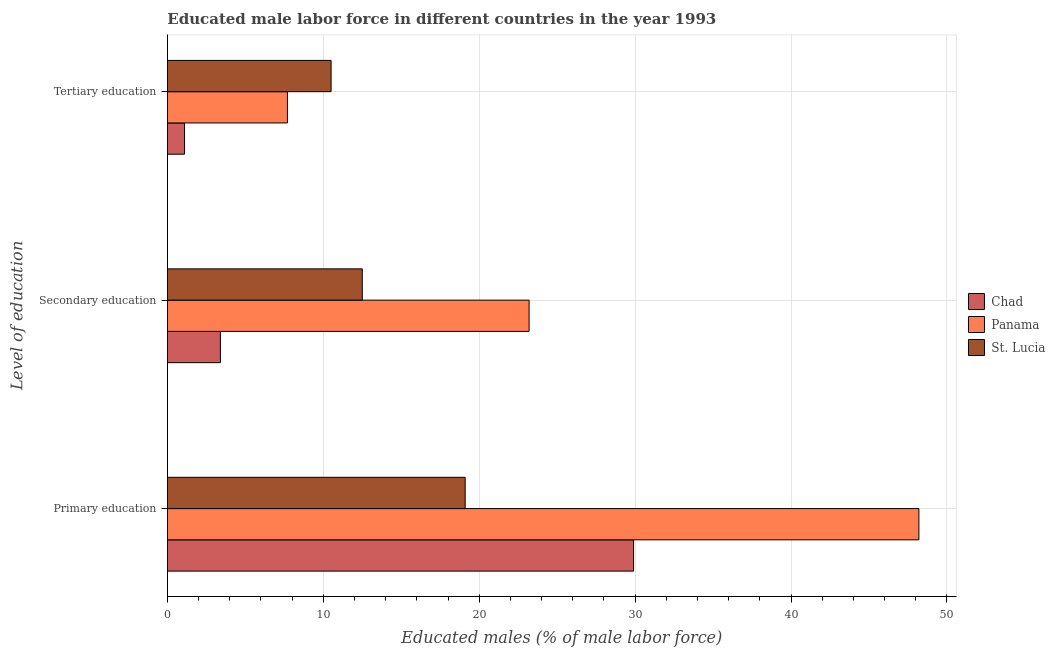How many groups of bars are there?
Ensure brevity in your answer.  3. Are the number of bars per tick equal to the number of legend labels?
Make the answer very short. Yes. What is the label of the 2nd group of bars from the top?
Your answer should be compact. Secondary education. What is the percentage of male labor force who received tertiary education in St. Lucia?
Your response must be concise. 10.5. Across all countries, what is the maximum percentage of male labor force who received primary education?
Offer a very short reply. 48.2. Across all countries, what is the minimum percentage of male labor force who received secondary education?
Make the answer very short. 3.4. In which country was the percentage of male labor force who received tertiary education maximum?
Offer a terse response. St. Lucia. In which country was the percentage of male labor force who received secondary education minimum?
Your response must be concise. Chad. What is the total percentage of male labor force who received primary education in the graph?
Make the answer very short. 97.2. What is the difference between the percentage of male labor force who received primary education in Chad and that in St. Lucia?
Your answer should be compact. 10.8. What is the difference between the percentage of male labor force who received secondary education in Chad and the percentage of male labor force who received primary education in St. Lucia?
Provide a short and direct response. -15.7. What is the average percentage of male labor force who received primary education per country?
Provide a short and direct response. 32.4. What is the difference between the percentage of male labor force who received primary education and percentage of male labor force who received tertiary education in Panama?
Provide a short and direct response. 40.5. What is the ratio of the percentage of male labor force who received tertiary education in Chad to that in Panama?
Offer a very short reply. 0.14. Is the percentage of male labor force who received primary education in Panama less than that in Chad?
Ensure brevity in your answer.  No. Is the difference between the percentage of male labor force who received secondary education in Panama and St. Lucia greater than the difference between the percentage of male labor force who received tertiary education in Panama and St. Lucia?
Provide a succinct answer. Yes. What is the difference between the highest and the second highest percentage of male labor force who received tertiary education?
Provide a short and direct response. 2.8. What is the difference between the highest and the lowest percentage of male labor force who received secondary education?
Your answer should be compact. 19.8. Is the sum of the percentage of male labor force who received secondary education in Chad and St. Lucia greater than the maximum percentage of male labor force who received primary education across all countries?
Provide a short and direct response. No. What does the 2nd bar from the top in Tertiary education represents?
Ensure brevity in your answer.  Panama. What does the 1st bar from the bottom in Primary education represents?
Ensure brevity in your answer.  Chad. Is it the case that in every country, the sum of the percentage of male labor force who received primary education and percentage of male labor force who received secondary education is greater than the percentage of male labor force who received tertiary education?
Your answer should be very brief. Yes. How many bars are there?
Make the answer very short. 9. Are all the bars in the graph horizontal?
Ensure brevity in your answer.  Yes. Does the graph contain any zero values?
Provide a short and direct response. No. Does the graph contain grids?
Your answer should be compact. Yes. How many legend labels are there?
Offer a terse response. 3. What is the title of the graph?
Provide a short and direct response. Educated male labor force in different countries in the year 1993. What is the label or title of the X-axis?
Ensure brevity in your answer.  Educated males (% of male labor force). What is the label or title of the Y-axis?
Make the answer very short. Level of education. What is the Educated males (% of male labor force) in Chad in Primary education?
Offer a terse response. 29.9. What is the Educated males (% of male labor force) of Panama in Primary education?
Make the answer very short. 48.2. What is the Educated males (% of male labor force) in St. Lucia in Primary education?
Give a very brief answer. 19.1. What is the Educated males (% of male labor force) in Chad in Secondary education?
Provide a short and direct response. 3.4. What is the Educated males (% of male labor force) in Panama in Secondary education?
Ensure brevity in your answer.  23.2. What is the Educated males (% of male labor force) of St. Lucia in Secondary education?
Your answer should be very brief. 12.5. What is the Educated males (% of male labor force) in Chad in Tertiary education?
Offer a terse response. 1.1. What is the Educated males (% of male labor force) of Panama in Tertiary education?
Your answer should be compact. 7.7. What is the Educated males (% of male labor force) in St. Lucia in Tertiary education?
Ensure brevity in your answer.  10.5. Across all Level of education, what is the maximum Educated males (% of male labor force) in Chad?
Offer a terse response. 29.9. Across all Level of education, what is the maximum Educated males (% of male labor force) of Panama?
Keep it short and to the point. 48.2. Across all Level of education, what is the maximum Educated males (% of male labor force) in St. Lucia?
Keep it short and to the point. 19.1. Across all Level of education, what is the minimum Educated males (% of male labor force) of Chad?
Your answer should be compact. 1.1. Across all Level of education, what is the minimum Educated males (% of male labor force) in Panama?
Offer a terse response. 7.7. Across all Level of education, what is the minimum Educated males (% of male labor force) in St. Lucia?
Provide a succinct answer. 10.5. What is the total Educated males (% of male labor force) in Chad in the graph?
Make the answer very short. 34.4. What is the total Educated males (% of male labor force) of Panama in the graph?
Your response must be concise. 79.1. What is the total Educated males (% of male labor force) in St. Lucia in the graph?
Ensure brevity in your answer.  42.1. What is the difference between the Educated males (% of male labor force) of Chad in Primary education and that in Secondary education?
Offer a very short reply. 26.5. What is the difference between the Educated males (% of male labor force) of Panama in Primary education and that in Secondary education?
Make the answer very short. 25. What is the difference between the Educated males (% of male labor force) of Chad in Primary education and that in Tertiary education?
Give a very brief answer. 28.8. What is the difference between the Educated males (% of male labor force) in Panama in Primary education and that in Tertiary education?
Make the answer very short. 40.5. What is the difference between the Educated males (% of male labor force) in Chad in Secondary education and that in Tertiary education?
Offer a very short reply. 2.3. What is the difference between the Educated males (% of male labor force) of Chad in Primary education and the Educated males (% of male labor force) of St. Lucia in Secondary education?
Your answer should be compact. 17.4. What is the difference between the Educated males (% of male labor force) in Panama in Primary education and the Educated males (% of male labor force) in St. Lucia in Secondary education?
Keep it short and to the point. 35.7. What is the difference between the Educated males (% of male labor force) in Chad in Primary education and the Educated males (% of male labor force) in St. Lucia in Tertiary education?
Offer a very short reply. 19.4. What is the difference between the Educated males (% of male labor force) of Panama in Primary education and the Educated males (% of male labor force) of St. Lucia in Tertiary education?
Keep it short and to the point. 37.7. What is the difference between the Educated males (% of male labor force) of Chad in Secondary education and the Educated males (% of male labor force) of St. Lucia in Tertiary education?
Make the answer very short. -7.1. What is the difference between the Educated males (% of male labor force) in Panama in Secondary education and the Educated males (% of male labor force) in St. Lucia in Tertiary education?
Give a very brief answer. 12.7. What is the average Educated males (% of male labor force) of Chad per Level of education?
Ensure brevity in your answer.  11.47. What is the average Educated males (% of male labor force) of Panama per Level of education?
Your response must be concise. 26.37. What is the average Educated males (% of male labor force) in St. Lucia per Level of education?
Your response must be concise. 14.03. What is the difference between the Educated males (% of male labor force) of Chad and Educated males (% of male labor force) of Panama in Primary education?
Offer a very short reply. -18.3. What is the difference between the Educated males (% of male labor force) in Chad and Educated males (% of male labor force) in St. Lucia in Primary education?
Your response must be concise. 10.8. What is the difference between the Educated males (% of male labor force) of Panama and Educated males (% of male labor force) of St. Lucia in Primary education?
Your answer should be compact. 29.1. What is the difference between the Educated males (% of male labor force) in Chad and Educated males (% of male labor force) in Panama in Secondary education?
Your response must be concise. -19.8. What is the difference between the Educated males (% of male labor force) of Chad and Educated males (% of male labor force) of St. Lucia in Secondary education?
Keep it short and to the point. -9.1. What is the difference between the Educated males (% of male labor force) of Panama and Educated males (% of male labor force) of St. Lucia in Secondary education?
Your answer should be very brief. 10.7. What is the ratio of the Educated males (% of male labor force) in Chad in Primary education to that in Secondary education?
Make the answer very short. 8.79. What is the ratio of the Educated males (% of male labor force) of Panama in Primary education to that in Secondary education?
Provide a short and direct response. 2.08. What is the ratio of the Educated males (% of male labor force) in St. Lucia in Primary education to that in Secondary education?
Offer a very short reply. 1.53. What is the ratio of the Educated males (% of male labor force) of Chad in Primary education to that in Tertiary education?
Ensure brevity in your answer.  27.18. What is the ratio of the Educated males (% of male labor force) in Panama in Primary education to that in Tertiary education?
Make the answer very short. 6.26. What is the ratio of the Educated males (% of male labor force) in St. Lucia in Primary education to that in Tertiary education?
Give a very brief answer. 1.82. What is the ratio of the Educated males (% of male labor force) of Chad in Secondary education to that in Tertiary education?
Your answer should be very brief. 3.09. What is the ratio of the Educated males (% of male labor force) in Panama in Secondary education to that in Tertiary education?
Provide a succinct answer. 3.01. What is the ratio of the Educated males (% of male labor force) in St. Lucia in Secondary education to that in Tertiary education?
Ensure brevity in your answer.  1.19. What is the difference between the highest and the second highest Educated males (% of male labor force) of Chad?
Your answer should be very brief. 26.5. What is the difference between the highest and the second highest Educated males (% of male labor force) of Panama?
Offer a very short reply. 25. What is the difference between the highest and the second highest Educated males (% of male labor force) of St. Lucia?
Make the answer very short. 6.6. What is the difference between the highest and the lowest Educated males (% of male labor force) in Chad?
Offer a very short reply. 28.8. What is the difference between the highest and the lowest Educated males (% of male labor force) in Panama?
Offer a very short reply. 40.5. What is the difference between the highest and the lowest Educated males (% of male labor force) in St. Lucia?
Give a very brief answer. 8.6. 